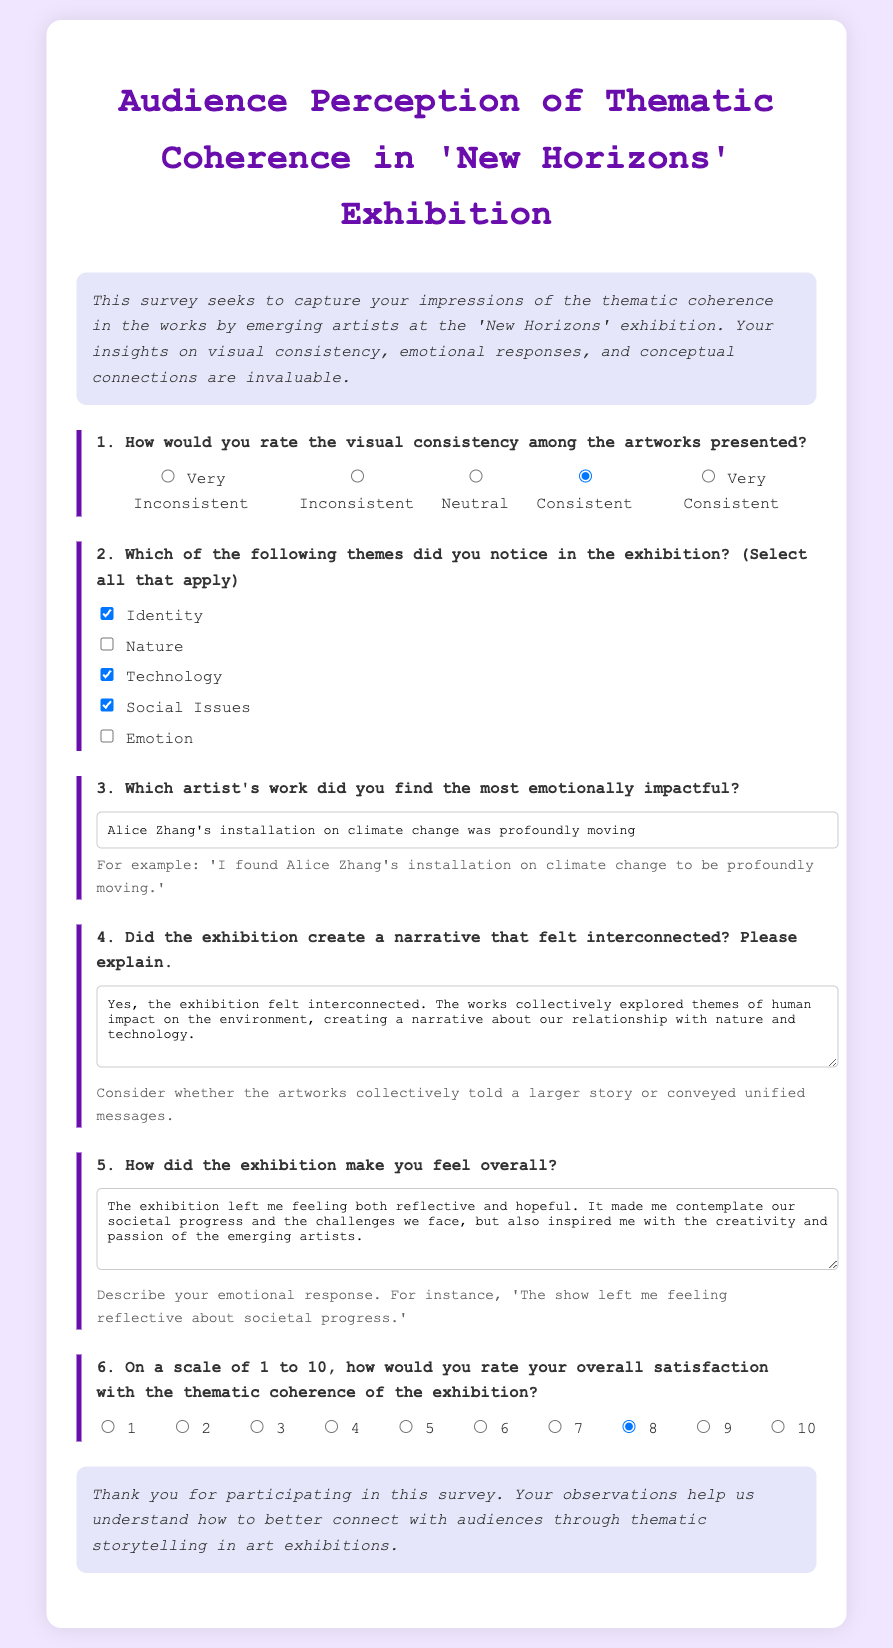What is the title of the survey? The title of the survey is presented prominently at the top of the document.
Answer: Audience Perception of Thematic Coherence in 'New Horizons' Exhibition How many themes could be selected in the survey? The survey indicates multiple-choice options for themes, which implies there are several to select from.
Answer: Five Which artist's work prompted the most emotional impact according to the example answer? The example answer provided mentions a specific artist and their installation related to climate change.
Answer: Alice Zhang's installation What was the overall satisfaction rating selected in the example? The survey includes a rating scale from 1 to 10, and the example answer indicates a specific rating for satisfaction.
Answer: 8 Did the exhibition create an interconnected narrative according to the example response? The question allows for a yes/no answer, and the example answer confirms the existence of such a narrative.
Answer: Yes What is the question that asks for the emotional response? The document includes multiple questions, and one specifically requests the respondent's feelings about the exhibition.
Answer: How did the exhibition make you feel overall? What rating option is available for visual consistency? The survey includes a set of options for rating visual consistency, meant to gauge perceptions on this aspect.
Answer: 1 to 5 What does the introduction emphasize about the survey? The introduction section outlines the purpose of the survey regarding audience impressions, focusing on specific aspects of the exhibition.
Answer: Thematic coherence Which theme was not selected in the multiple-choice section? The survey allows respondents to select themes and provides options that may or may not be checked in the example.
Answer: Nature 